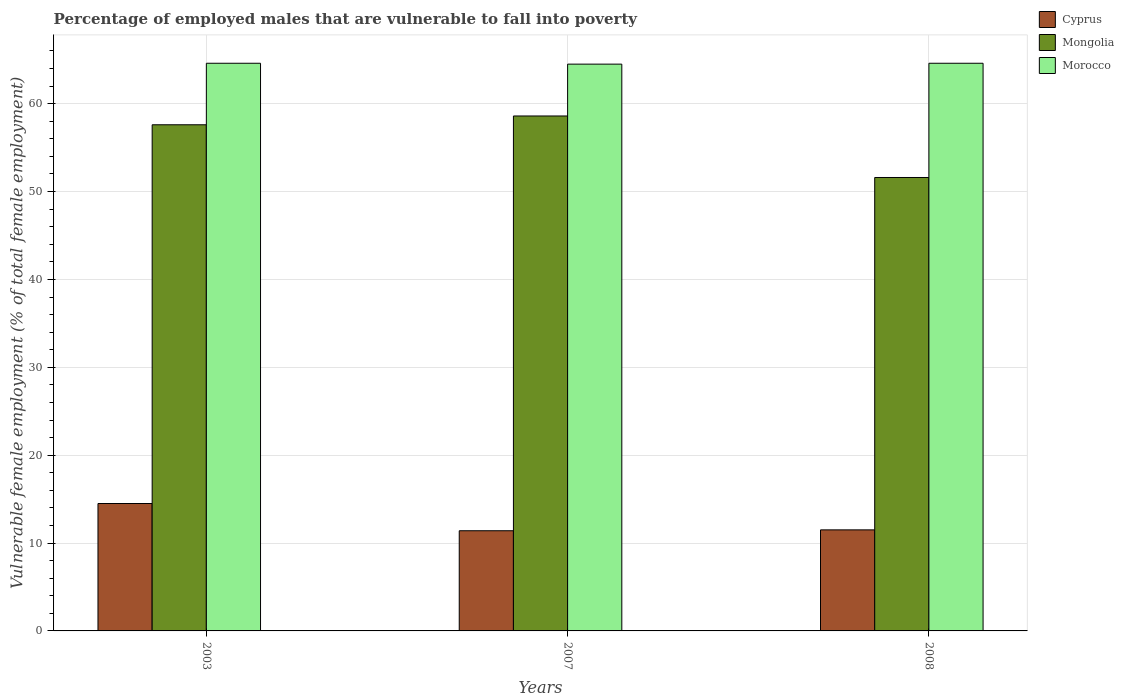How many groups of bars are there?
Provide a short and direct response. 3. Are the number of bars per tick equal to the number of legend labels?
Give a very brief answer. Yes. Are the number of bars on each tick of the X-axis equal?
Offer a very short reply. Yes. How many bars are there on the 1st tick from the left?
Your response must be concise. 3. In how many cases, is the number of bars for a given year not equal to the number of legend labels?
Provide a short and direct response. 0. What is the percentage of employed males who are vulnerable to fall into poverty in Cyprus in 2007?
Give a very brief answer. 11.4. Across all years, what is the minimum percentage of employed males who are vulnerable to fall into poverty in Cyprus?
Offer a very short reply. 11.4. In which year was the percentage of employed males who are vulnerable to fall into poverty in Mongolia minimum?
Keep it short and to the point. 2008. What is the total percentage of employed males who are vulnerable to fall into poverty in Cyprus in the graph?
Ensure brevity in your answer.  37.4. What is the difference between the percentage of employed males who are vulnerable to fall into poverty in Cyprus in 2003 and that in 2008?
Your answer should be compact. 3. What is the difference between the percentage of employed males who are vulnerable to fall into poverty in Morocco in 2007 and the percentage of employed males who are vulnerable to fall into poverty in Cyprus in 2003?
Provide a short and direct response. 50. What is the average percentage of employed males who are vulnerable to fall into poverty in Morocco per year?
Provide a short and direct response. 64.57. In the year 2003, what is the difference between the percentage of employed males who are vulnerable to fall into poverty in Cyprus and percentage of employed males who are vulnerable to fall into poverty in Morocco?
Your response must be concise. -50.1. In how many years, is the percentage of employed males who are vulnerable to fall into poverty in Mongolia greater than 4 %?
Ensure brevity in your answer.  3. What is the ratio of the percentage of employed males who are vulnerable to fall into poverty in Cyprus in 2007 to that in 2008?
Provide a succinct answer. 0.99. Is the percentage of employed males who are vulnerable to fall into poverty in Cyprus in 2003 less than that in 2008?
Your response must be concise. No. Is the sum of the percentage of employed males who are vulnerable to fall into poverty in Mongolia in 2007 and 2008 greater than the maximum percentage of employed males who are vulnerable to fall into poverty in Morocco across all years?
Your answer should be very brief. Yes. What does the 1st bar from the left in 2003 represents?
Offer a terse response. Cyprus. What does the 1st bar from the right in 2003 represents?
Your response must be concise. Morocco. Is it the case that in every year, the sum of the percentage of employed males who are vulnerable to fall into poverty in Mongolia and percentage of employed males who are vulnerable to fall into poverty in Morocco is greater than the percentage of employed males who are vulnerable to fall into poverty in Cyprus?
Offer a terse response. Yes. How many years are there in the graph?
Ensure brevity in your answer.  3. What is the difference between two consecutive major ticks on the Y-axis?
Your response must be concise. 10. Does the graph contain grids?
Offer a very short reply. Yes. How many legend labels are there?
Your answer should be very brief. 3. How are the legend labels stacked?
Your response must be concise. Vertical. What is the title of the graph?
Ensure brevity in your answer.  Percentage of employed males that are vulnerable to fall into poverty. What is the label or title of the Y-axis?
Offer a terse response. Vulnerable female employment (% of total female employment). What is the Vulnerable female employment (% of total female employment) of Mongolia in 2003?
Offer a terse response. 57.6. What is the Vulnerable female employment (% of total female employment) of Morocco in 2003?
Offer a terse response. 64.6. What is the Vulnerable female employment (% of total female employment) in Cyprus in 2007?
Ensure brevity in your answer.  11.4. What is the Vulnerable female employment (% of total female employment) of Mongolia in 2007?
Offer a terse response. 58.6. What is the Vulnerable female employment (% of total female employment) in Morocco in 2007?
Your response must be concise. 64.5. What is the Vulnerable female employment (% of total female employment) of Mongolia in 2008?
Give a very brief answer. 51.6. What is the Vulnerable female employment (% of total female employment) in Morocco in 2008?
Your answer should be compact. 64.6. Across all years, what is the maximum Vulnerable female employment (% of total female employment) of Mongolia?
Ensure brevity in your answer.  58.6. Across all years, what is the maximum Vulnerable female employment (% of total female employment) of Morocco?
Provide a short and direct response. 64.6. Across all years, what is the minimum Vulnerable female employment (% of total female employment) of Cyprus?
Ensure brevity in your answer.  11.4. Across all years, what is the minimum Vulnerable female employment (% of total female employment) in Mongolia?
Ensure brevity in your answer.  51.6. Across all years, what is the minimum Vulnerable female employment (% of total female employment) of Morocco?
Offer a very short reply. 64.5. What is the total Vulnerable female employment (% of total female employment) in Cyprus in the graph?
Your answer should be very brief. 37.4. What is the total Vulnerable female employment (% of total female employment) in Mongolia in the graph?
Give a very brief answer. 167.8. What is the total Vulnerable female employment (% of total female employment) in Morocco in the graph?
Make the answer very short. 193.7. What is the difference between the Vulnerable female employment (% of total female employment) of Mongolia in 2003 and that in 2007?
Offer a very short reply. -1. What is the difference between the Vulnerable female employment (% of total female employment) in Mongolia in 2007 and that in 2008?
Provide a succinct answer. 7. What is the difference between the Vulnerable female employment (% of total female employment) in Morocco in 2007 and that in 2008?
Your answer should be very brief. -0.1. What is the difference between the Vulnerable female employment (% of total female employment) in Cyprus in 2003 and the Vulnerable female employment (% of total female employment) in Mongolia in 2007?
Offer a terse response. -44.1. What is the difference between the Vulnerable female employment (% of total female employment) of Mongolia in 2003 and the Vulnerable female employment (% of total female employment) of Morocco in 2007?
Your answer should be very brief. -6.9. What is the difference between the Vulnerable female employment (% of total female employment) in Cyprus in 2003 and the Vulnerable female employment (% of total female employment) in Mongolia in 2008?
Provide a succinct answer. -37.1. What is the difference between the Vulnerable female employment (% of total female employment) of Cyprus in 2003 and the Vulnerable female employment (% of total female employment) of Morocco in 2008?
Your response must be concise. -50.1. What is the difference between the Vulnerable female employment (% of total female employment) in Mongolia in 2003 and the Vulnerable female employment (% of total female employment) in Morocco in 2008?
Your answer should be very brief. -7. What is the difference between the Vulnerable female employment (% of total female employment) of Cyprus in 2007 and the Vulnerable female employment (% of total female employment) of Mongolia in 2008?
Your response must be concise. -40.2. What is the difference between the Vulnerable female employment (% of total female employment) in Cyprus in 2007 and the Vulnerable female employment (% of total female employment) in Morocco in 2008?
Give a very brief answer. -53.2. What is the average Vulnerable female employment (% of total female employment) in Cyprus per year?
Offer a terse response. 12.47. What is the average Vulnerable female employment (% of total female employment) in Mongolia per year?
Keep it short and to the point. 55.93. What is the average Vulnerable female employment (% of total female employment) of Morocco per year?
Make the answer very short. 64.57. In the year 2003, what is the difference between the Vulnerable female employment (% of total female employment) in Cyprus and Vulnerable female employment (% of total female employment) in Mongolia?
Ensure brevity in your answer.  -43.1. In the year 2003, what is the difference between the Vulnerable female employment (% of total female employment) of Cyprus and Vulnerable female employment (% of total female employment) of Morocco?
Offer a terse response. -50.1. In the year 2003, what is the difference between the Vulnerable female employment (% of total female employment) of Mongolia and Vulnerable female employment (% of total female employment) of Morocco?
Your answer should be very brief. -7. In the year 2007, what is the difference between the Vulnerable female employment (% of total female employment) in Cyprus and Vulnerable female employment (% of total female employment) in Mongolia?
Provide a succinct answer. -47.2. In the year 2007, what is the difference between the Vulnerable female employment (% of total female employment) in Cyprus and Vulnerable female employment (% of total female employment) in Morocco?
Provide a succinct answer. -53.1. In the year 2007, what is the difference between the Vulnerable female employment (% of total female employment) of Mongolia and Vulnerable female employment (% of total female employment) of Morocco?
Your response must be concise. -5.9. In the year 2008, what is the difference between the Vulnerable female employment (% of total female employment) of Cyprus and Vulnerable female employment (% of total female employment) of Mongolia?
Your response must be concise. -40.1. In the year 2008, what is the difference between the Vulnerable female employment (% of total female employment) in Cyprus and Vulnerable female employment (% of total female employment) in Morocco?
Your answer should be very brief. -53.1. What is the ratio of the Vulnerable female employment (% of total female employment) of Cyprus in 2003 to that in 2007?
Offer a very short reply. 1.27. What is the ratio of the Vulnerable female employment (% of total female employment) in Mongolia in 2003 to that in 2007?
Make the answer very short. 0.98. What is the ratio of the Vulnerable female employment (% of total female employment) of Morocco in 2003 to that in 2007?
Your answer should be compact. 1. What is the ratio of the Vulnerable female employment (% of total female employment) in Cyprus in 2003 to that in 2008?
Your answer should be very brief. 1.26. What is the ratio of the Vulnerable female employment (% of total female employment) of Mongolia in 2003 to that in 2008?
Your answer should be very brief. 1.12. What is the ratio of the Vulnerable female employment (% of total female employment) in Mongolia in 2007 to that in 2008?
Your answer should be compact. 1.14. What is the ratio of the Vulnerable female employment (% of total female employment) of Morocco in 2007 to that in 2008?
Ensure brevity in your answer.  1. What is the difference between the highest and the second highest Vulnerable female employment (% of total female employment) of Cyprus?
Your answer should be very brief. 3. What is the difference between the highest and the second highest Vulnerable female employment (% of total female employment) in Mongolia?
Your answer should be very brief. 1. What is the difference between the highest and the lowest Vulnerable female employment (% of total female employment) of Morocco?
Provide a succinct answer. 0.1. 